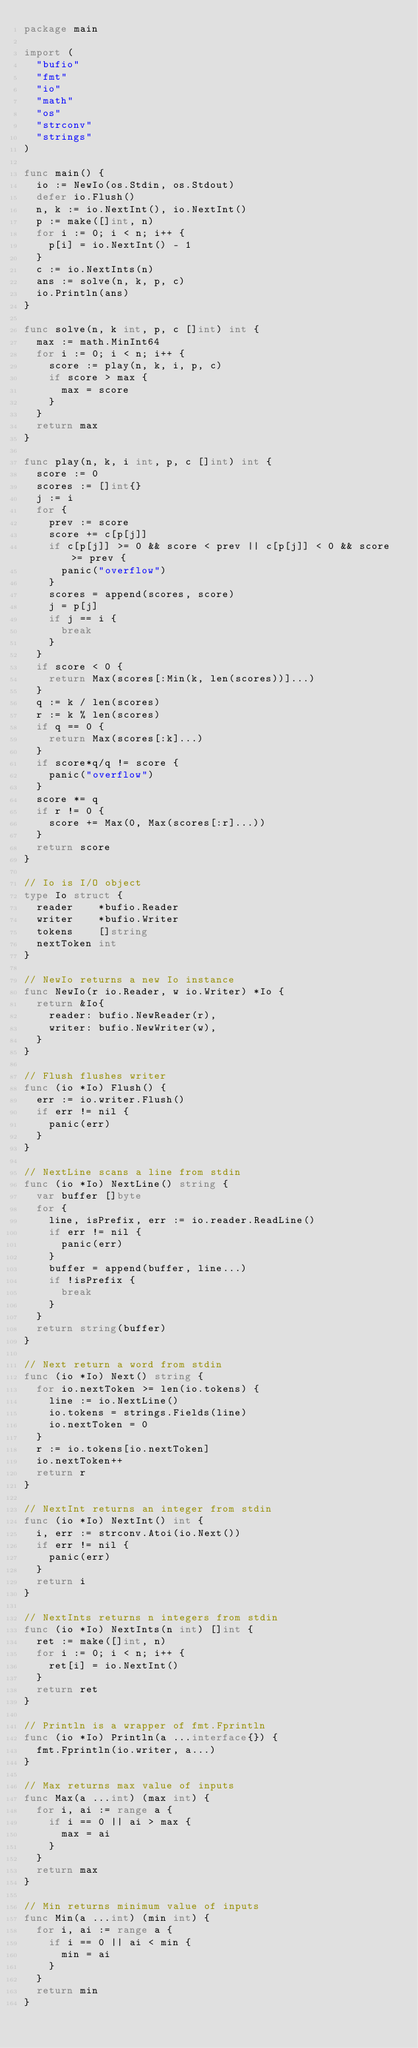Convert code to text. <code><loc_0><loc_0><loc_500><loc_500><_Go_>package main

import (
	"bufio"
	"fmt"
	"io"
	"math"
	"os"
	"strconv"
	"strings"
)

func main() {
	io := NewIo(os.Stdin, os.Stdout)
	defer io.Flush()
	n, k := io.NextInt(), io.NextInt()
	p := make([]int, n)
	for i := 0; i < n; i++ {
		p[i] = io.NextInt() - 1
	}
	c := io.NextInts(n)
	ans := solve(n, k, p, c)
	io.Println(ans)
}

func solve(n, k int, p, c []int) int {
	max := math.MinInt64
	for i := 0; i < n; i++ {
		score := play(n, k, i, p, c)
		if score > max {
			max = score
		}
	}
	return max
}

func play(n, k, i int, p, c []int) int {
	score := 0
	scores := []int{}
	j := i
	for {
		prev := score
		score += c[p[j]]
		if c[p[j]] >= 0 && score < prev || c[p[j]] < 0 && score >= prev {
			panic("overflow")
		}
		scores = append(scores, score)
		j = p[j]
		if j == i {
			break
		}
	}
	if score < 0 {
		return Max(scores[:Min(k, len(scores))]...)
	}
	q := k / len(scores)
	r := k % len(scores)
	if q == 0 {
		return Max(scores[:k]...)
	}
	if score*q/q != score {
		panic("overflow")
	}
	score *= q
	if r != 0 {
		score += Max(0, Max(scores[:r]...))
	}
	return score
}

// Io is I/O object
type Io struct {
	reader    *bufio.Reader
	writer    *bufio.Writer
	tokens    []string
	nextToken int
}

// NewIo returns a new Io instance
func NewIo(r io.Reader, w io.Writer) *Io {
	return &Io{
		reader: bufio.NewReader(r),
		writer: bufio.NewWriter(w),
	}
}

// Flush flushes writer
func (io *Io) Flush() {
	err := io.writer.Flush()
	if err != nil {
		panic(err)
	}
}

// NextLine scans a line from stdin
func (io *Io) NextLine() string {
	var buffer []byte
	for {
		line, isPrefix, err := io.reader.ReadLine()
		if err != nil {
			panic(err)
		}
		buffer = append(buffer, line...)
		if !isPrefix {
			break
		}
	}
	return string(buffer)
}

// Next return a word from stdin
func (io *Io) Next() string {
	for io.nextToken >= len(io.tokens) {
		line := io.NextLine()
		io.tokens = strings.Fields(line)
		io.nextToken = 0
	}
	r := io.tokens[io.nextToken]
	io.nextToken++
	return r
}

// NextInt returns an integer from stdin
func (io *Io) NextInt() int {
	i, err := strconv.Atoi(io.Next())
	if err != nil {
		panic(err)
	}
	return i
}

// NextInts returns n integers from stdin
func (io *Io) NextInts(n int) []int {
	ret := make([]int, n)
	for i := 0; i < n; i++ {
		ret[i] = io.NextInt()
	}
	return ret
}

// Println is a wrapper of fmt.Fprintln
func (io *Io) Println(a ...interface{}) {
	fmt.Fprintln(io.writer, a...)
}

// Max returns max value of inputs
func Max(a ...int) (max int) {
	for i, ai := range a {
		if i == 0 || ai > max {
			max = ai
		}
	}
	return max
}

// Min returns minimum value of inputs
func Min(a ...int) (min int) {
	for i, ai := range a {
		if i == 0 || ai < min {
			min = ai
		}
	}
	return min
}
</code> 